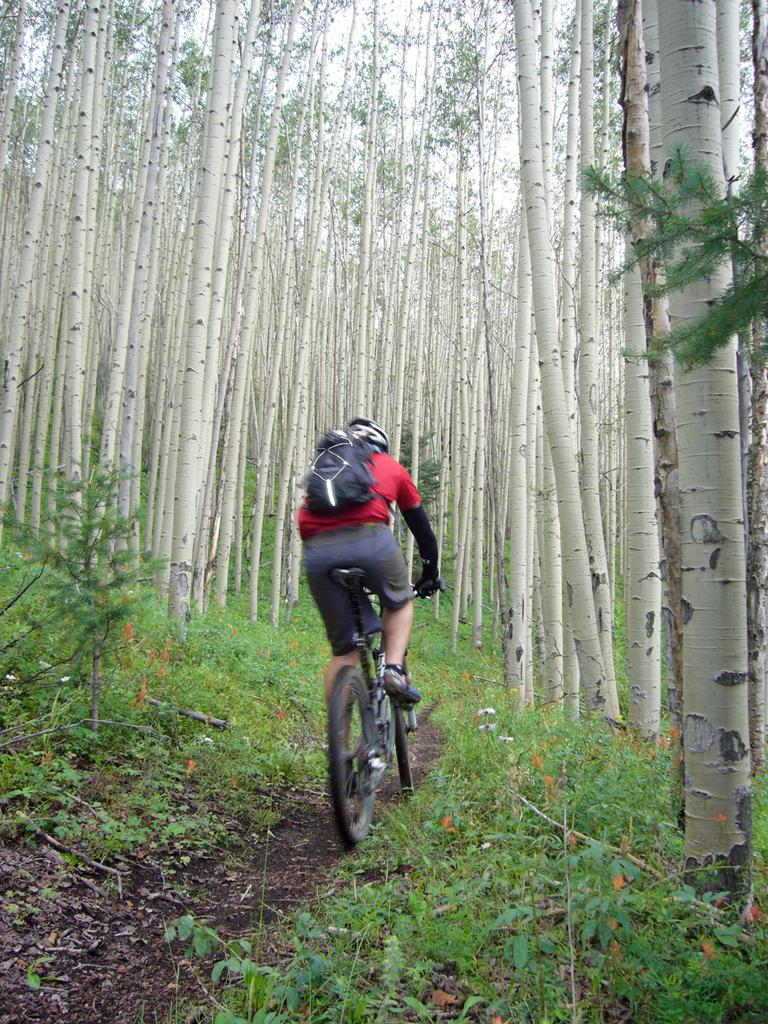What is the person in the image doing? The person in the image is cycling. Where is the cycling taking place? The cycling is taking place in a forest. Can you describe the forest in the image? The forest is full of trees and contains plants. What is the person wearing or carrying that might be useful for their activity? The person has a backpack on. What type of paste can be seen on the person's hands in the image? There is no paste visible on the person's hands in the image. Is there a swing present in the forest where the person is cycling? There is no mention of a swing in the image or the provided facts. 